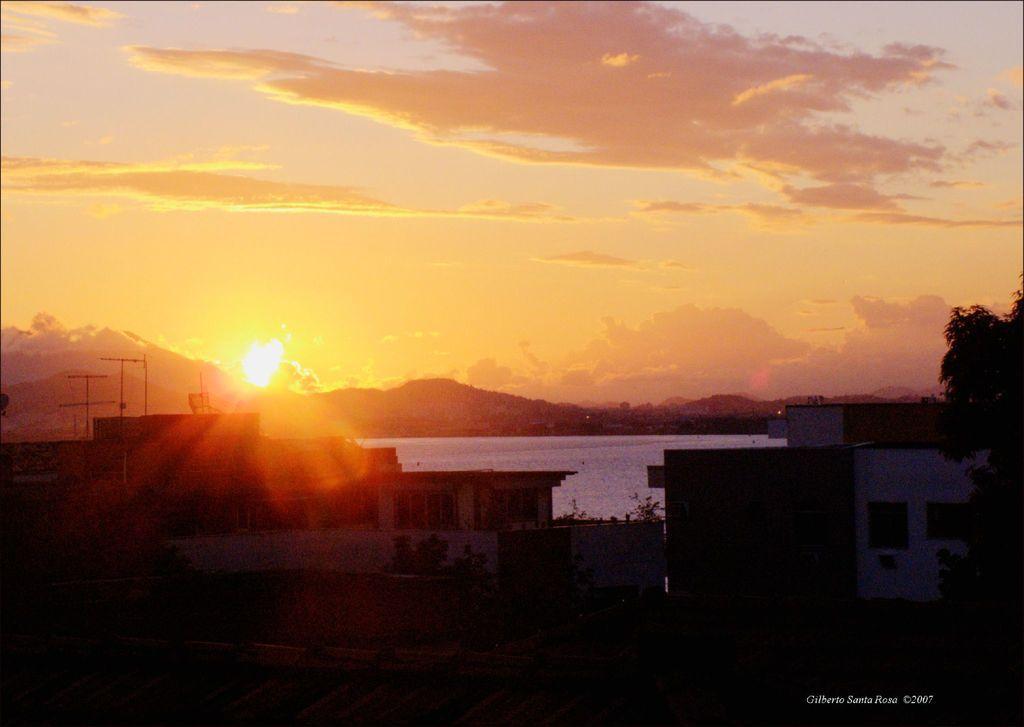Can you describe this image briefly? In this picture we can see buildings with windows, trees, mountains and in the background we can see the sky with clouds. 